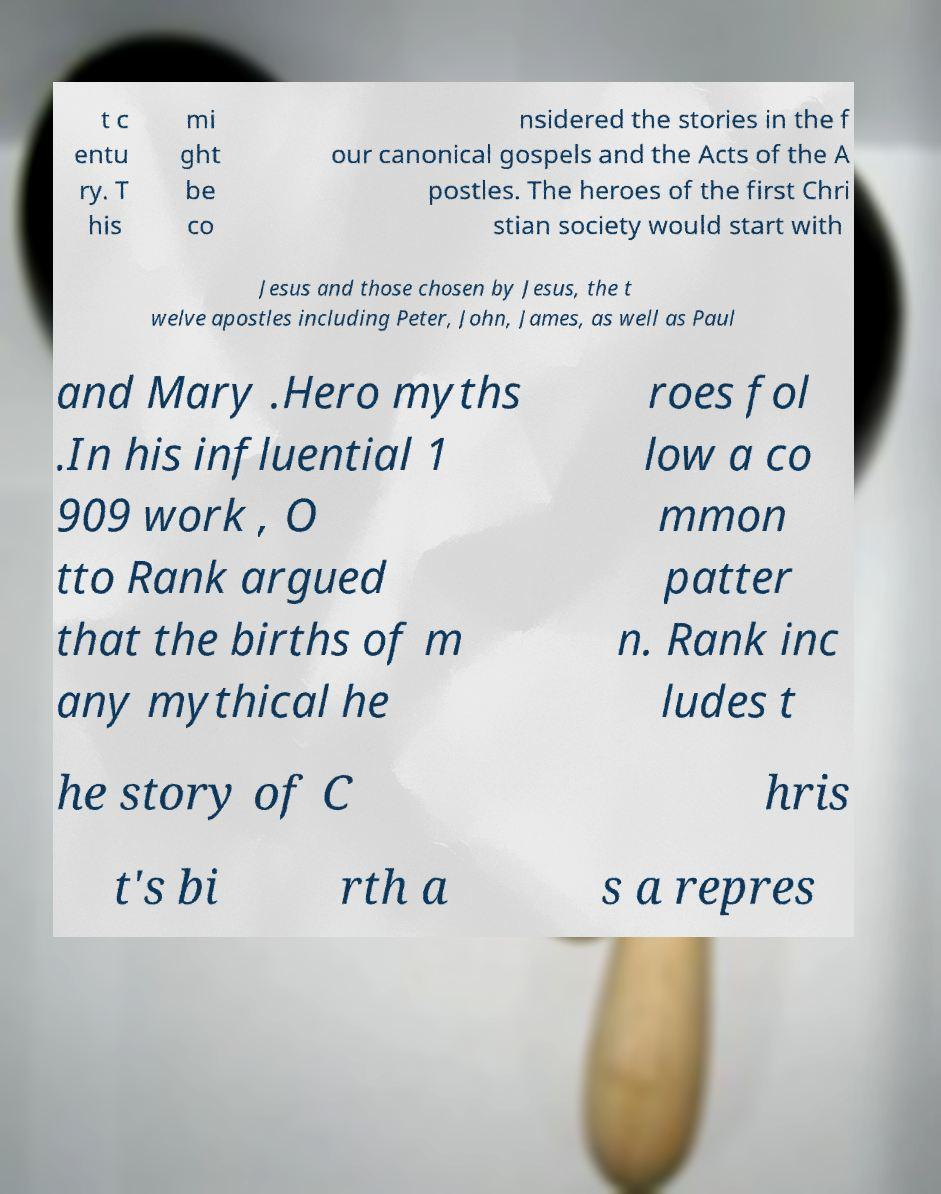Can you accurately transcribe the text from the provided image for me? t c entu ry. T his mi ght be co nsidered the stories in the f our canonical gospels and the Acts of the A postles. The heroes of the first Chri stian society would start with Jesus and those chosen by Jesus, the t welve apostles including Peter, John, James, as well as Paul and Mary .Hero myths .In his influential 1 909 work , O tto Rank argued that the births of m any mythical he roes fol low a co mmon patter n. Rank inc ludes t he story of C hris t's bi rth a s a repres 